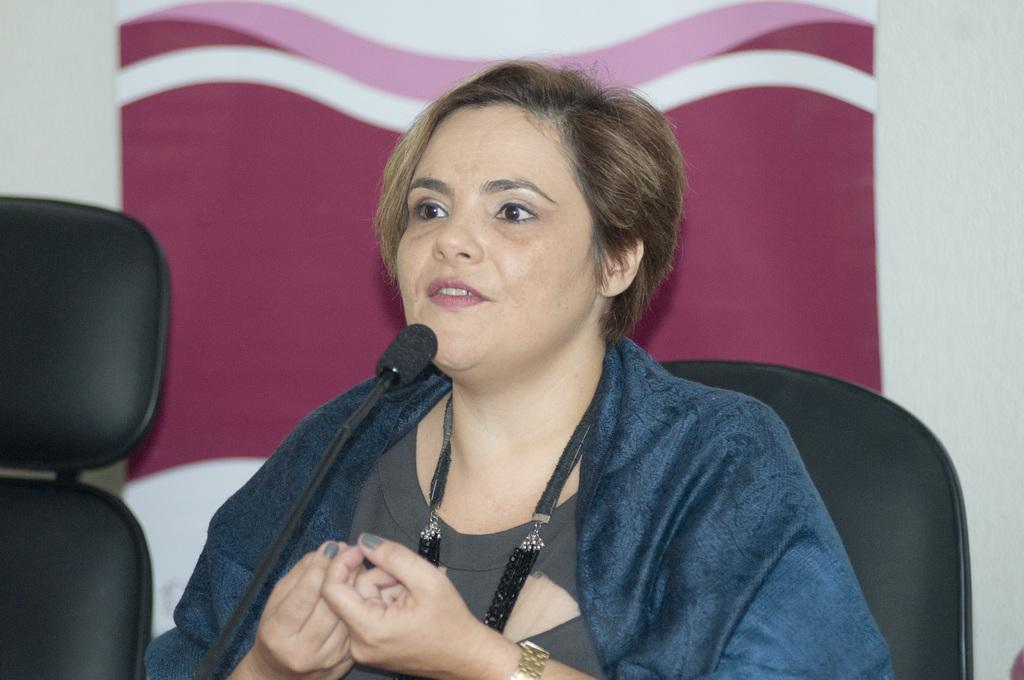Who is the main subject in the picture? There is a woman in the center of the picture. What is the woman doing in the picture? The woman is sitting in a chair and talking into a microphone. Are there any other chairs visible in the picture? Yes, there is a chair on the left side of the picture. What can be seen in the background of the picture? There is a banner in the background of the picture. What type of fish can be seen swimming in the background of the picture? There are no fish present in the image; it features a woman sitting in a chair and talking into a microphone, with a banner in the background. 